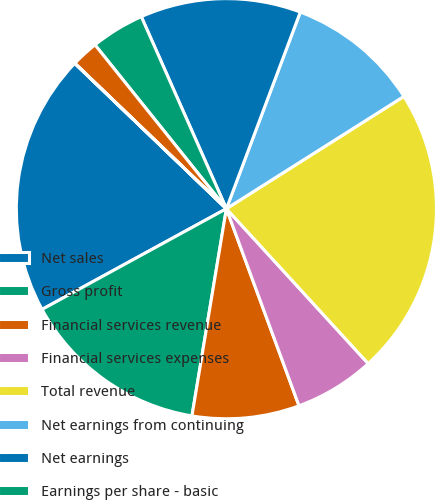Convert chart to OTSL. <chart><loc_0><loc_0><loc_500><loc_500><pie_chart><fcel>Net sales<fcel>Gross profit<fcel>Financial services revenue<fcel>Financial services expenses<fcel>Total revenue<fcel>Net earnings from continuing<fcel>Net earnings<fcel>Earnings per share - basic<fcel>Earnings per share - diluted<fcel>Cash dividends paid per share<nl><fcel>20.12%<fcel>14.42%<fcel>8.24%<fcel>6.18%<fcel>22.18%<fcel>10.3%<fcel>12.36%<fcel>4.12%<fcel>2.07%<fcel>0.01%<nl></chart> 